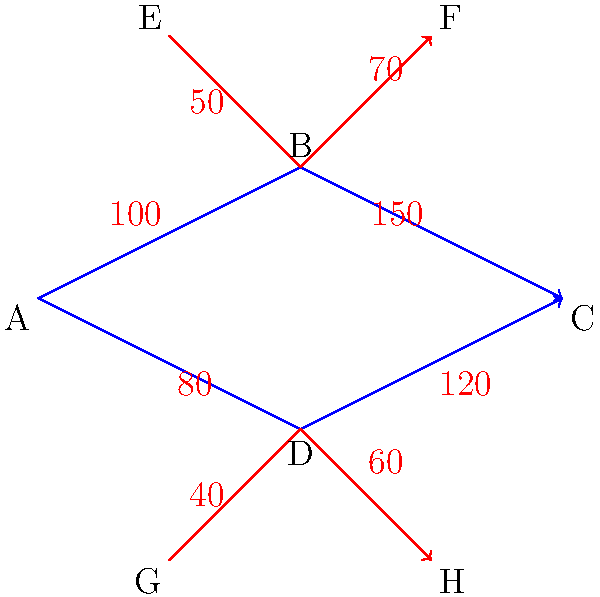Based on the evacuation route diagram, which path should be prioritized to optimize the flow of evacuees from point A to point C, and what is the maximum flow rate that can be achieved? To solve this problem, we'll use the concept of maximum flow in a network. Let's break it down step-by-step:

1. Identify the paths from A to C:
   Path 1: A -> B -> C
   Path 2: A -> D -> C

2. Calculate the flow rates for each path:
   Path 1: min(100, 150) = 100
   Path 2: min(80, 120) = 80

3. The maximum flow is the sum of the flows through all paths:
   Maximum flow = 100 + 80 = 180

4. To optimize the evacuation, we should prioritize the path with the higher flow rate:
   Path 1 (A -> B -> C) has a higher flow rate (100) compared to Path 2 (80).

5. Additional considerations:
   - The paths E -> B -> F and G -> D -> H can affect the flow at points B and D respectively.
   - However, these additional flows (50 and 40) are less than the main path capacities, so they don't increase the overall maximum flow from A to C.

Therefore, to optimize the evacuation:
1. Prioritize the path A -> B -> C
2. Utilize the path A -> D -> C as a secondary route
3. The maximum achievable flow rate is 180 evacuees per unit time
Answer: Prioritize A -> B -> C; Maximum flow rate: 180 